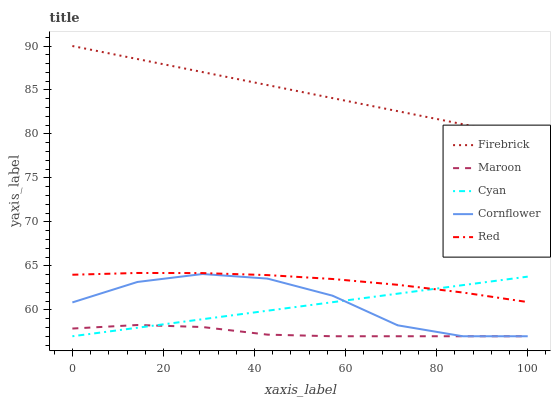Does Maroon have the minimum area under the curve?
Answer yes or no. Yes. Does Firebrick have the maximum area under the curve?
Answer yes or no. Yes. Does Red have the minimum area under the curve?
Answer yes or no. No. Does Red have the maximum area under the curve?
Answer yes or no. No. Is Cyan the smoothest?
Answer yes or no. Yes. Is Cornflower the roughest?
Answer yes or no. Yes. Is Firebrick the smoothest?
Answer yes or no. No. Is Firebrick the roughest?
Answer yes or no. No. Does Cyan have the lowest value?
Answer yes or no. Yes. Does Red have the lowest value?
Answer yes or no. No. Does Firebrick have the highest value?
Answer yes or no. Yes. Does Red have the highest value?
Answer yes or no. No. Is Cyan less than Firebrick?
Answer yes or no. Yes. Is Red greater than Maroon?
Answer yes or no. Yes. Does Cyan intersect Maroon?
Answer yes or no. Yes. Is Cyan less than Maroon?
Answer yes or no. No. Is Cyan greater than Maroon?
Answer yes or no. No. Does Cyan intersect Firebrick?
Answer yes or no. No. 